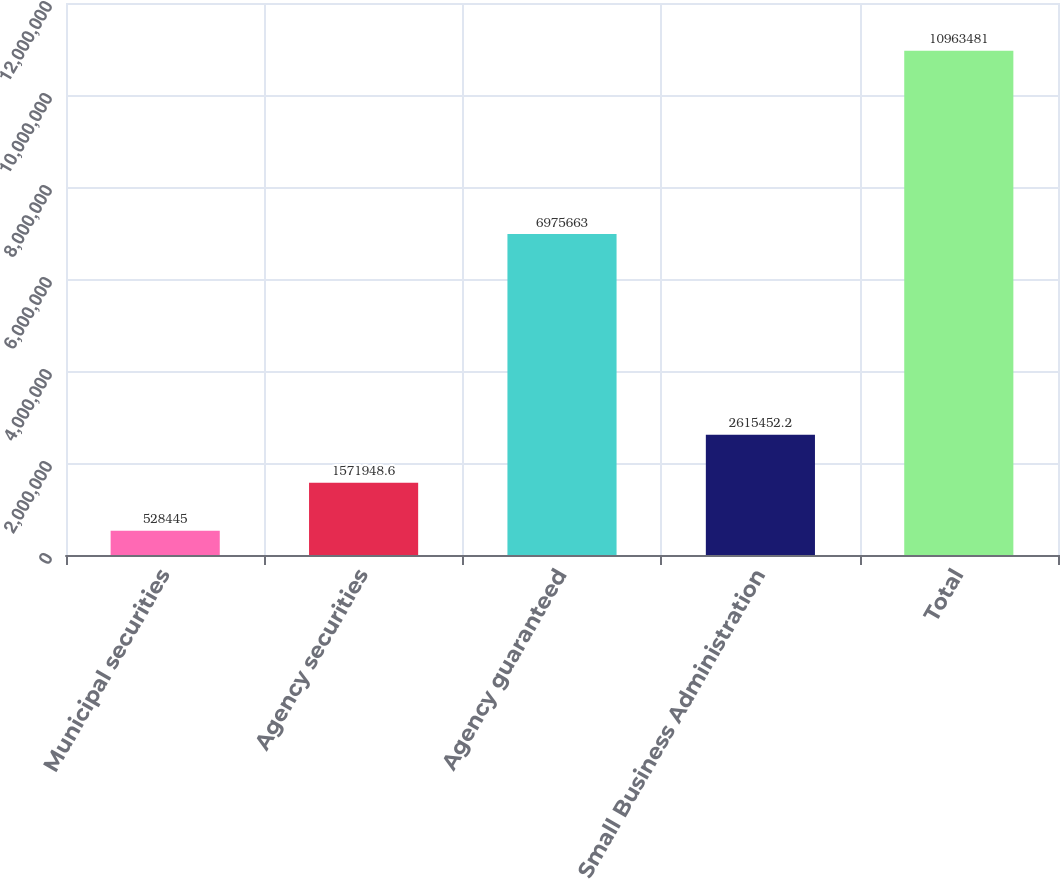<chart> <loc_0><loc_0><loc_500><loc_500><bar_chart><fcel>Municipal securities<fcel>Agency securities<fcel>Agency guaranteed<fcel>Small Business Administration<fcel>Total<nl><fcel>528445<fcel>1.57195e+06<fcel>6.97566e+06<fcel>2.61545e+06<fcel>1.09635e+07<nl></chart> 